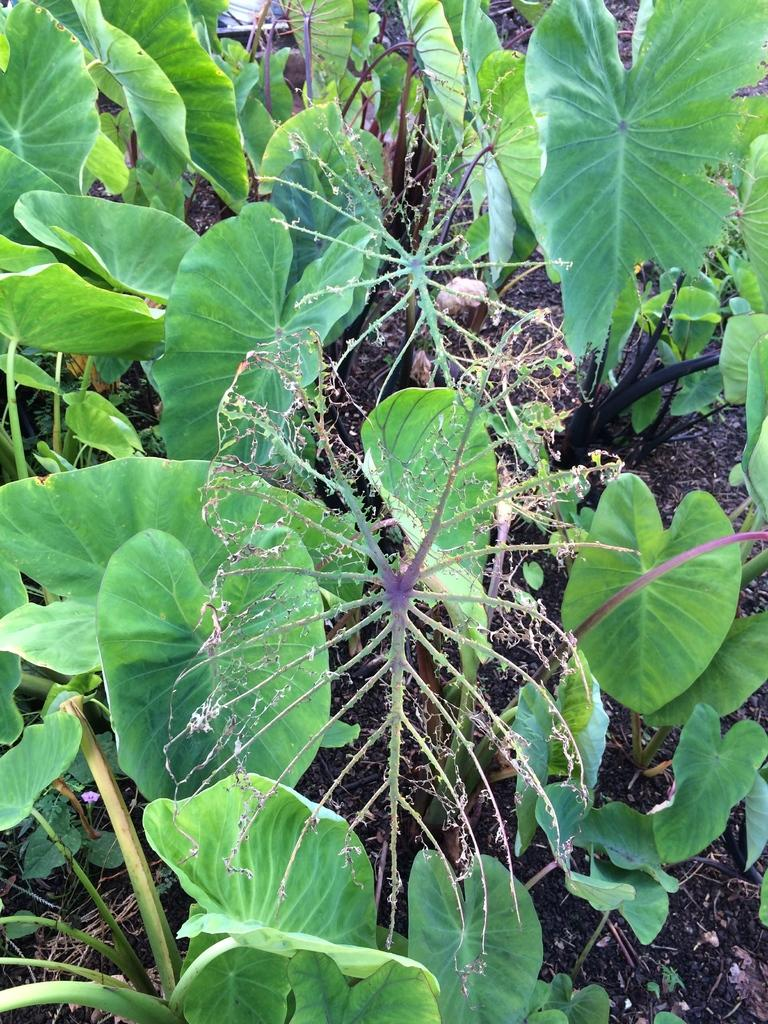What type of vegetation can be seen in the image? There are leaves in the image. What type of ground is visible in the image? There is black soil in the image. What verse is recited by the leaves in the image? There are no verses or any form of recitation in the image; it simply shows leaves and black soil. 